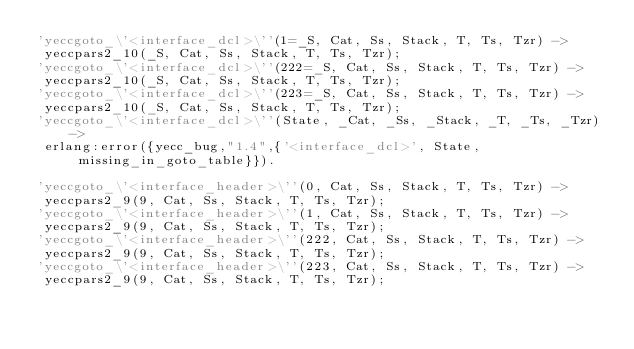Convert code to text. <code><loc_0><loc_0><loc_500><loc_500><_Erlang_>'yeccgoto_\'<interface_dcl>\''(1=_S, Cat, Ss, Stack, T, Ts, Tzr) ->
 yeccpars2_10(_S, Cat, Ss, Stack, T, Ts, Tzr);
'yeccgoto_\'<interface_dcl>\''(222=_S, Cat, Ss, Stack, T, Ts, Tzr) ->
 yeccpars2_10(_S, Cat, Ss, Stack, T, Ts, Tzr);
'yeccgoto_\'<interface_dcl>\''(223=_S, Cat, Ss, Stack, T, Ts, Tzr) ->
 yeccpars2_10(_S, Cat, Ss, Stack, T, Ts, Tzr);
'yeccgoto_\'<interface_dcl>\''(State, _Cat, _Ss, _Stack, _T, _Ts, _Tzr) ->
 erlang:error({yecc_bug,"1.4",{'<interface_dcl>', State, missing_in_goto_table}}).

'yeccgoto_\'<interface_header>\''(0, Cat, Ss, Stack, T, Ts, Tzr) ->
 yeccpars2_9(9, Cat, Ss, Stack, T, Ts, Tzr);
'yeccgoto_\'<interface_header>\''(1, Cat, Ss, Stack, T, Ts, Tzr) ->
 yeccpars2_9(9, Cat, Ss, Stack, T, Ts, Tzr);
'yeccgoto_\'<interface_header>\''(222, Cat, Ss, Stack, T, Ts, Tzr) ->
 yeccpars2_9(9, Cat, Ss, Stack, T, Ts, Tzr);
'yeccgoto_\'<interface_header>\''(223, Cat, Ss, Stack, T, Ts, Tzr) ->
 yeccpars2_9(9, Cat, Ss, Stack, T, Ts, Tzr);</code> 